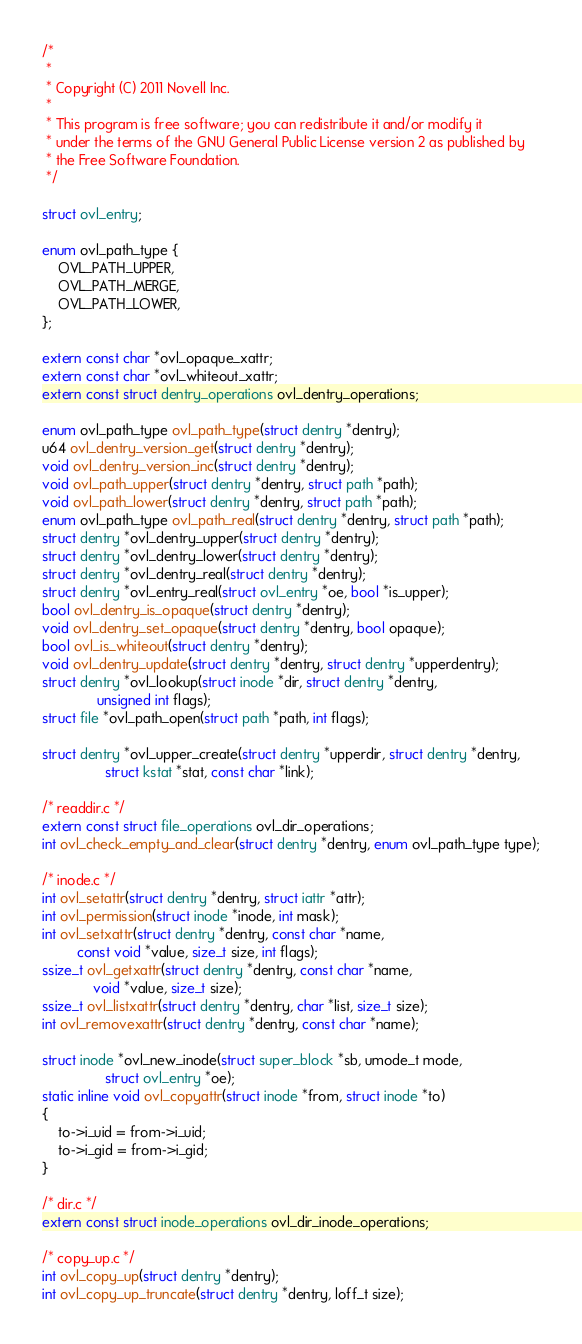Convert code to text. <code><loc_0><loc_0><loc_500><loc_500><_C_>/*
 *
 * Copyright (C) 2011 Novell Inc.
 *
 * This program is free software; you can redistribute it and/or modify it
 * under the terms of the GNU General Public License version 2 as published by
 * the Free Software Foundation.
 */

struct ovl_entry;

enum ovl_path_type {
	OVL_PATH_UPPER,
	OVL_PATH_MERGE,
	OVL_PATH_LOWER,
};

extern const char *ovl_opaque_xattr;
extern const char *ovl_whiteout_xattr;
extern const struct dentry_operations ovl_dentry_operations;

enum ovl_path_type ovl_path_type(struct dentry *dentry);
u64 ovl_dentry_version_get(struct dentry *dentry);
void ovl_dentry_version_inc(struct dentry *dentry);
void ovl_path_upper(struct dentry *dentry, struct path *path);
void ovl_path_lower(struct dentry *dentry, struct path *path);
enum ovl_path_type ovl_path_real(struct dentry *dentry, struct path *path);
struct dentry *ovl_dentry_upper(struct dentry *dentry);
struct dentry *ovl_dentry_lower(struct dentry *dentry);
struct dentry *ovl_dentry_real(struct dentry *dentry);
struct dentry *ovl_entry_real(struct ovl_entry *oe, bool *is_upper);
bool ovl_dentry_is_opaque(struct dentry *dentry);
void ovl_dentry_set_opaque(struct dentry *dentry, bool opaque);
bool ovl_is_whiteout(struct dentry *dentry);
void ovl_dentry_update(struct dentry *dentry, struct dentry *upperdentry);
struct dentry *ovl_lookup(struct inode *dir, struct dentry *dentry,
			  unsigned int flags);
struct file *ovl_path_open(struct path *path, int flags);

struct dentry *ovl_upper_create(struct dentry *upperdir, struct dentry *dentry,
				struct kstat *stat, const char *link);

/* readdir.c */
extern const struct file_operations ovl_dir_operations;
int ovl_check_empty_and_clear(struct dentry *dentry, enum ovl_path_type type);

/* inode.c */
int ovl_setattr(struct dentry *dentry, struct iattr *attr);
int ovl_permission(struct inode *inode, int mask);
int ovl_setxattr(struct dentry *dentry, const char *name,
		 const void *value, size_t size, int flags);
ssize_t ovl_getxattr(struct dentry *dentry, const char *name,
		     void *value, size_t size);
ssize_t ovl_listxattr(struct dentry *dentry, char *list, size_t size);
int ovl_removexattr(struct dentry *dentry, const char *name);

struct inode *ovl_new_inode(struct super_block *sb, umode_t mode,
			    struct ovl_entry *oe);
static inline void ovl_copyattr(struct inode *from, struct inode *to)
{
	to->i_uid = from->i_uid;
	to->i_gid = from->i_gid;
}

/* dir.c */
extern const struct inode_operations ovl_dir_inode_operations;

/* copy_up.c */
int ovl_copy_up(struct dentry *dentry);
int ovl_copy_up_truncate(struct dentry *dentry, loff_t size);
</code> 